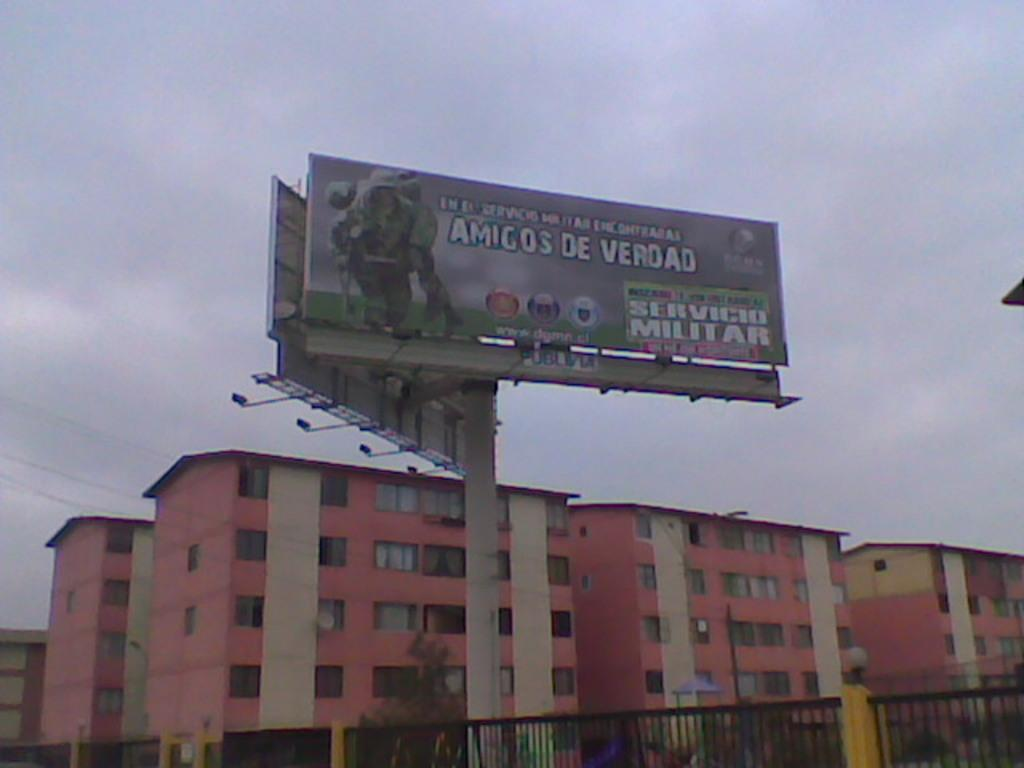<image>
Offer a succinct explanation of the picture presented. A billboard about Amigos de Verdad shows a man in uniform carrying someone on their back. 